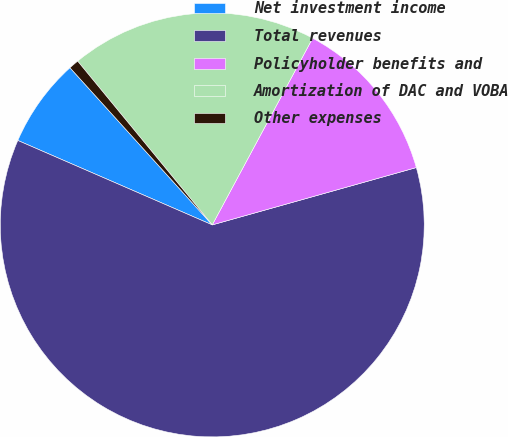Convert chart. <chart><loc_0><loc_0><loc_500><loc_500><pie_chart><fcel>Net investment income<fcel>Total revenues<fcel>Policyholder benefits and<fcel>Amortization of DAC and VOBA<fcel>Other expenses<nl><fcel>6.77%<fcel>60.88%<fcel>12.79%<fcel>18.8%<fcel>0.76%<nl></chart> 